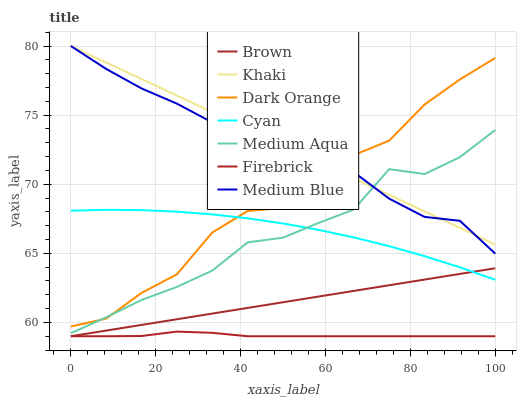Does Firebrick have the minimum area under the curve?
Answer yes or no. Yes. Does Khaki have the maximum area under the curve?
Answer yes or no. Yes. Does Dark Orange have the minimum area under the curve?
Answer yes or no. No. Does Dark Orange have the maximum area under the curve?
Answer yes or no. No. Is Brown the smoothest?
Answer yes or no. Yes. Is Dark Orange the roughest?
Answer yes or no. Yes. Is Khaki the smoothest?
Answer yes or no. No. Is Khaki the roughest?
Answer yes or no. No. Does Brown have the lowest value?
Answer yes or no. Yes. Does Dark Orange have the lowest value?
Answer yes or no. No. Does Medium Blue have the highest value?
Answer yes or no. Yes. Does Dark Orange have the highest value?
Answer yes or no. No. Is Firebrick less than Khaki?
Answer yes or no. Yes. Is Medium Blue greater than Firebrick?
Answer yes or no. Yes. Does Medium Blue intersect Dark Orange?
Answer yes or no. Yes. Is Medium Blue less than Dark Orange?
Answer yes or no. No. Is Medium Blue greater than Dark Orange?
Answer yes or no. No. Does Firebrick intersect Khaki?
Answer yes or no. No. 